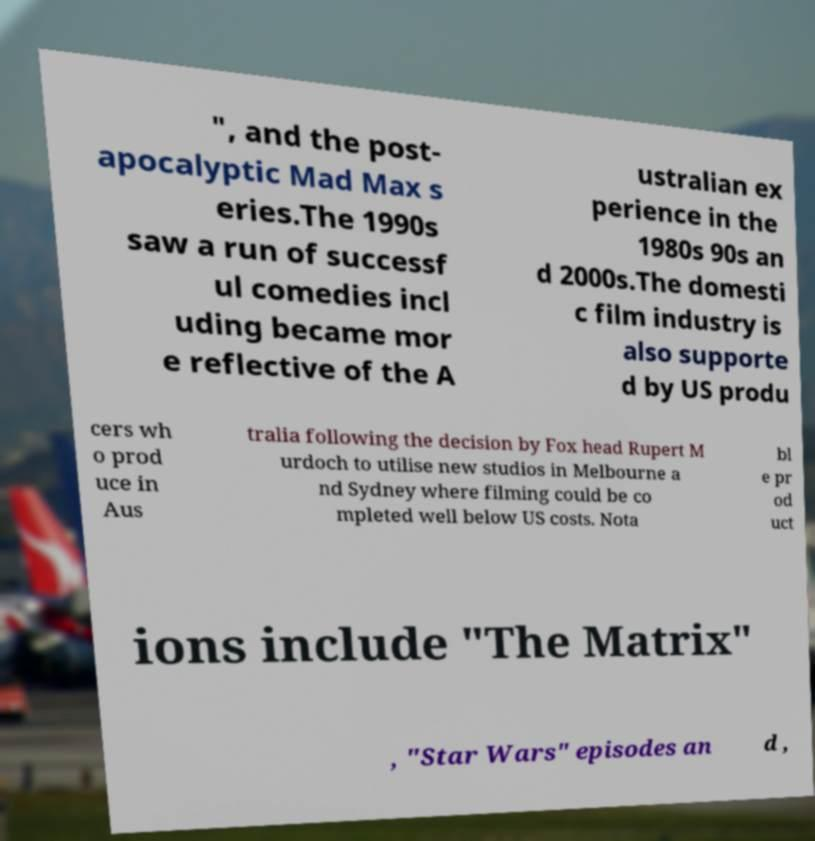There's text embedded in this image that I need extracted. Can you transcribe it verbatim? ", and the post- apocalyptic Mad Max s eries.The 1990s saw a run of successf ul comedies incl uding became mor e reflective of the A ustralian ex perience in the 1980s 90s an d 2000s.The domesti c film industry is also supporte d by US produ cers wh o prod uce in Aus tralia following the decision by Fox head Rupert M urdoch to utilise new studios in Melbourne a nd Sydney where filming could be co mpleted well below US costs. Nota bl e pr od uct ions include "The Matrix" , "Star Wars" episodes an d , 